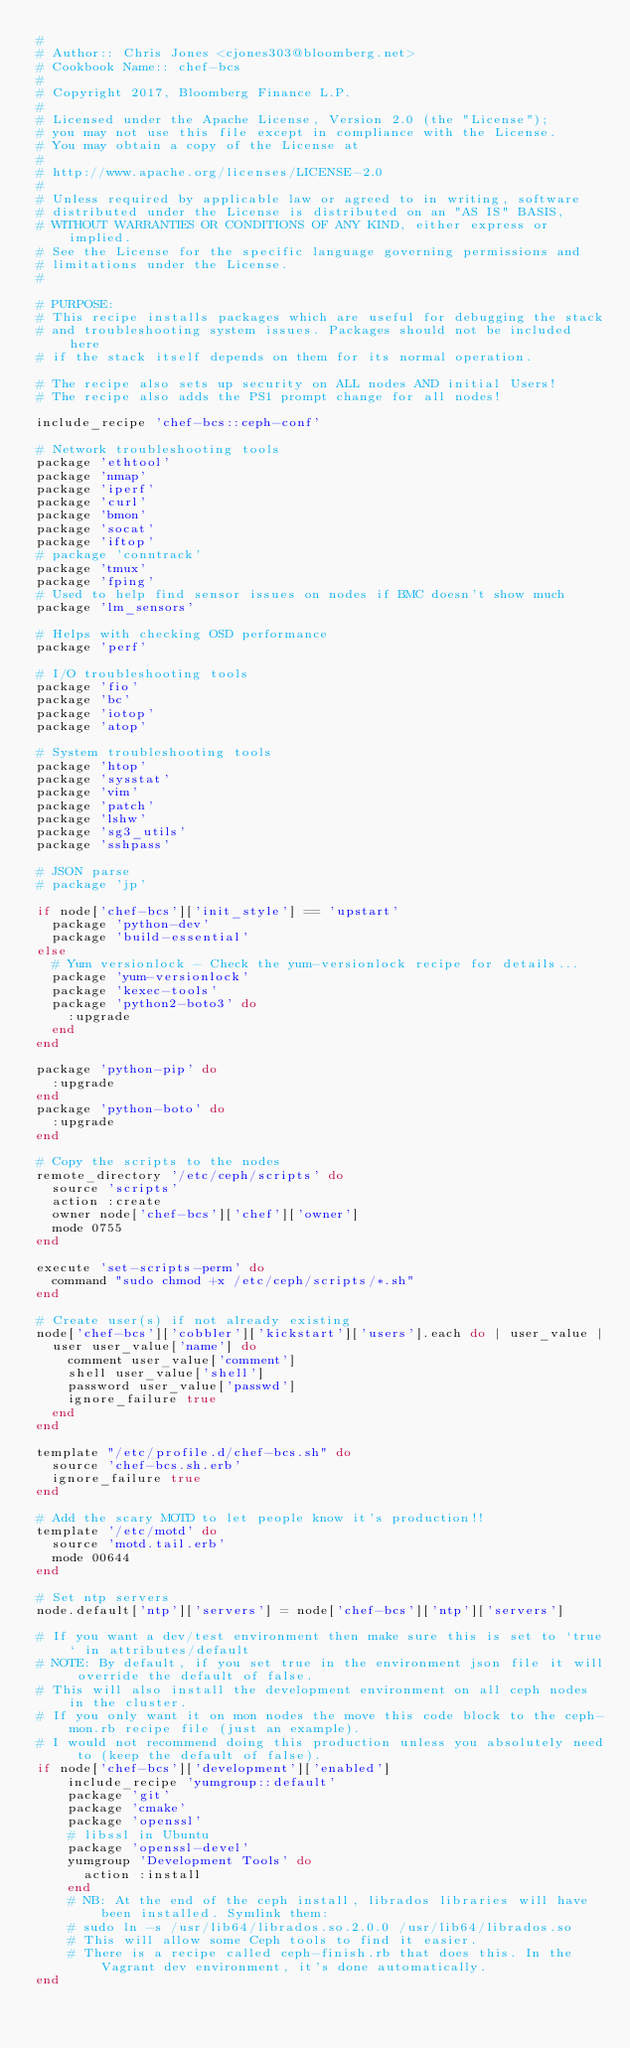Convert code to text. <code><loc_0><loc_0><loc_500><loc_500><_Ruby_>#
# Author:: Chris Jones <cjones303@bloomberg.net>
# Cookbook Name:: chef-bcs
#
# Copyright 2017, Bloomberg Finance L.P.
#
# Licensed under the Apache License, Version 2.0 (the "License");
# you may not use this file except in compliance with the License.
# You may obtain a copy of the License at
#
# http://www.apache.org/licenses/LICENSE-2.0
#
# Unless required by applicable law or agreed to in writing, software
# distributed under the License is distributed on an "AS IS" BASIS,
# WITHOUT WARRANTIES OR CONDITIONS OF ANY KIND, either express or implied.
# See the License for the specific language governing permissions and
# limitations under the License.
#

# PURPOSE:
# This recipe installs packages which are useful for debugging the stack
# and troubleshooting system issues. Packages should not be included here
# if the stack itself depends on them for its normal operation.

# The recipe also sets up security on ALL nodes AND initial Users!
# The recipe also adds the PS1 prompt change for all nodes!

include_recipe 'chef-bcs::ceph-conf'

# Network troubleshooting tools
package 'ethtool'
package 'nmap'
package 'iperf'
package 'curl'
package 'bmon'
package 'socat'
package 'iftop'
# package 'conntrack'
package 'tmux'
package 'fping'
# Used to help find sensor issues on nodes if BMC doesn't show much
package 'lm_sensors'

# Helps with checking OSD performance
package 'perf'

# I/O troubleshooting tools
package 'fio'
package 'bc'
package 'iotop'
package 'atop'

# System troubleshooting tools
package 'htop'
package 'sysstat'
package 'vim'
package 'patch'
package 'lshw'
package 'sg3_utils'
package 'sshpass'

# JSON parse
# package 'jp'

if node['chef-bcs']['init_style'] == 'upstart'
  package 'python-dev'
  package 'build-essential'
else
  # Yum versionlock - Check the yum-versionlock recipe for details...
  package 'yum-versionlock'
  package 'kexec-tools'
  package 'python2-boto3' do
    :upgrade
  end
end

package 'python-pip' do
  :upgrade
end
package 'python-boto' do
  :upgrade
end

# Copy the scripts to the nodes
remote_directory '/etc/ceph/scripts' do
  source 'scripts'
  action :create
  owner node['chef-bcs']['chef']['owner']
  mode 0755
end

execute 'set-scripts-perm' do
  command "sudo chmod +x /etc/ceph/scripts/*.sh"
end

# Create user(s) if not already existing
node['chef-bcs']['cobbler']['kickstart']['users'].each do | user_value |
  user user_value['name'] do
    comment user_value['comment']
    shell user_value['shell']
    password user_value['passwd']
    ignore_failure true
  end
end

template "/etc/profile.d/chef-bcs.sh" do
  source 'chef-bcs.sh.erb'
  ignore_failure true
end

# Add the scary MOTD to let people know it's production!!
template '/etc/motd' do
  source 'motd.tail.erb'
  mode 00644
end

# Set ntp servers
node.default['ntp']['servers'] = node['chef-bcs']['ntp']['servers']

# If you want a dev/test environment then make sure this is set to `true` in attributes/default
# NOTE: By default, if you set true in the environment json file it will override the default of false.
# This will also install the development environment on all ceph nodes in the cluster.
# If you only want it on mon nodes the move this code block to the ceph-mon.rb recipe file (just an example).
# I would not recommend doing this production unless you absolutely need to (keep the default of false).
if node['chef-bcs']['development']['enabled']
    include_recipe 'yumgroup::default'
    package 'git'
    package 'cmake'
    package 'openssl'
    # libssl in Ubuntu
    package 'openssl-devel'
    yumgroup 'Development Tools' do
      action :install
    end
    # NB: At the end of the ceph install, librados libraries will have been installed. Symlink them:
    # sudo ln -s /usr/lib64/librados.so.2.0.0 /usr/lib64/librados.so
    # This will allow some Ceph tools to find it easier.
    # There is a recipe called ceph-finish.rb that does this. In the Vagrant dev environment, it's done automatically.
end
</code> 